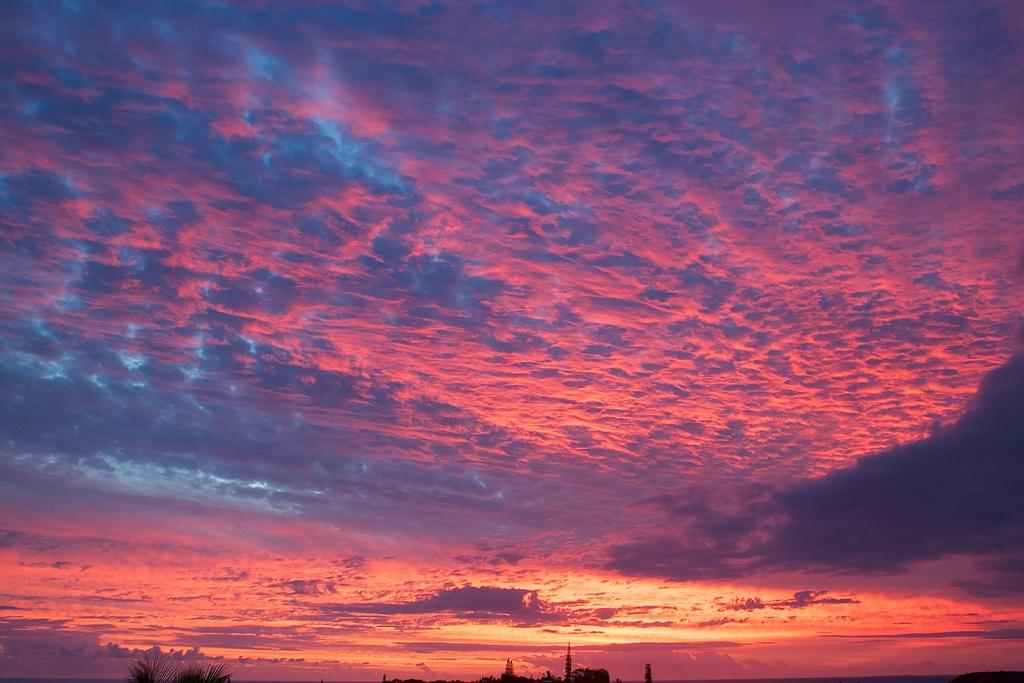What type of vegetation can be seen in the image? There are trees in the image. What is the condition of the sky in the image? The sky is cloudy in the image. Where is the waste disposal unit located in the image? There is no waste disposal unit present in the image. What type of adjustment can be seen being made to the trees in the image? There is no adjustment being made to the trees in the image; they are simply standing in their natural state. 